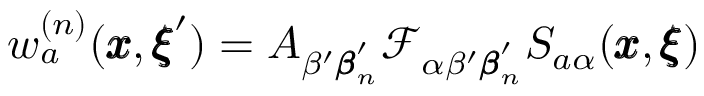Convert formula to latex. <formula><loc_0><loc_0><loc_500><loc_500>w _ { a } ^ { ( n ) } ( { \pm b x } , { \pm b \xi } ^ { \prime } ) = A _ { \beta ^ { \prime } { \pm b \beta } _ { n } ^ { \prime } } { \mathcal { F } _ { \alpha \beta ^ { \prime } { \pm b \beta } _ { n } ^ { \prime } } S _ { a \alpha } ( { \pm b x } , { \pm b \xi } ) }</formula> 